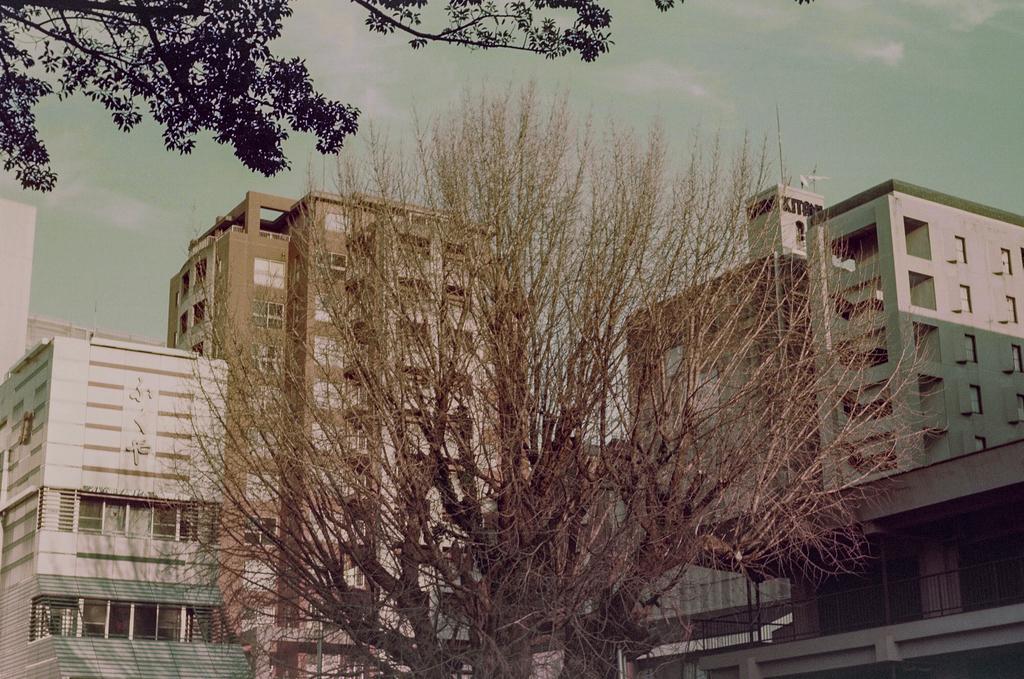In one or two sentences, can you explain what this image depicts? In this image I can see trees in green color, background I can see few buildings in brown and white color and the sky is in white color. 